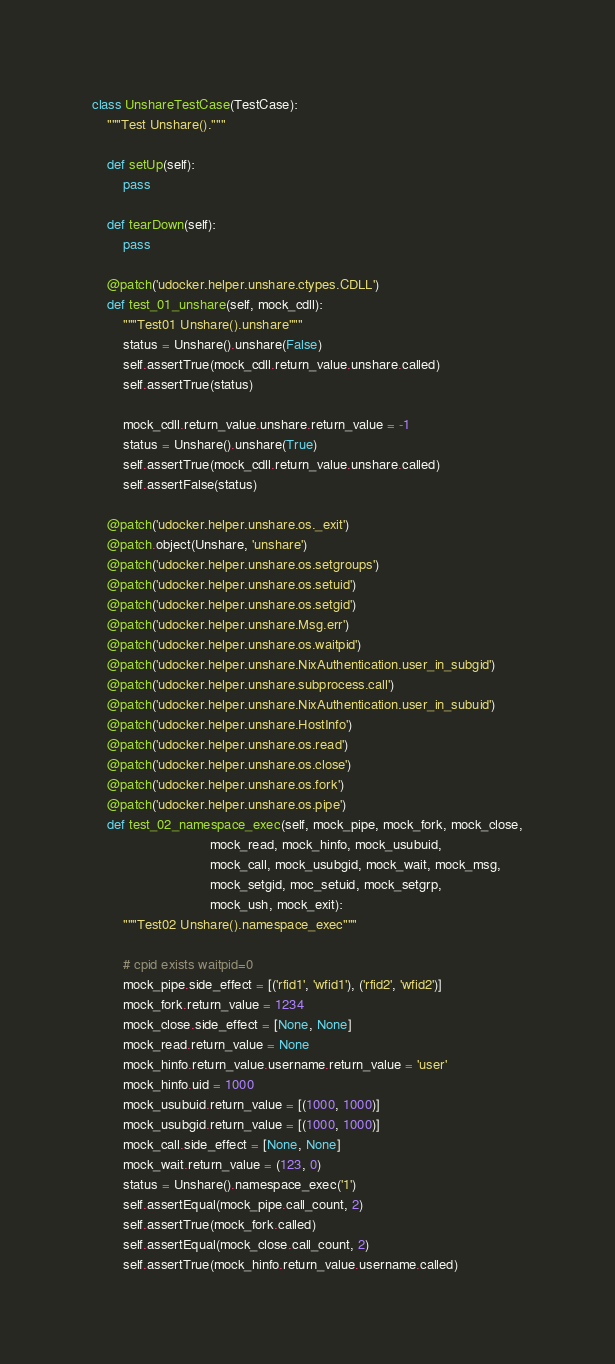Convert code to text. <code><loc_0><loc_0><loc_500><loc_500><_Python_>
class UnshareTestCase(TestCase):
    """Test Unshare()."""

    def setUp(self):
        pass

    def tearDown(self):
        pass

    @patch('udocker.helper.unshare.ctypes.CDLL')
    def test_01_unshare(self, mock_cdll):
        """Test01 Unshare().unshare"""
        status = Unshare().unshare(False)
        self.assertTrue(mock_cdll.return_value.unshare.called)
        self.assertTrue(status)

        mock_cdll.return_value.unshare.return_value = -1
        status = Unshare().unshare(True)
        self.assertTrue(mock_cdll.return_value.unshare.called)
        self.assertFalse(status)

    @patch('udocker.helper.unshare.os._exit')
    @patch.object(Unshare, 'unshare')
    @patch('udocker.helper.unshare.os.setgroups')
    @patch('udocker.helper.unshare.os.setuid')
    @patch('udocker.helper.unshare.os.setgid')
    @patch('udocker.helper.unshare.Msg.err')
    @patch('udocker.helper.unshare.os.waitpid')
    @patch('udocker.helper.unshare.NixAuthentication.user_in_subgid')
    @patch('udocker.helper.unshare.subprocess.call')
    @patch('udocker.helper.unshare.NixAuthentication.user_in_subuid')
    @patch('udocker.helper.unshare.HostInfo')
    @patch('udocker.helper.unshare.os.read')
    @patch('udocker.helper.unshare.os.close')
    @patch('udocker.helper.unshare.os.fork')
    @patch('udocker.helper.unshare.os.pipe')
    def test_02_namespace_exec(self, mock_pipe, mock_fork, mock_close,
                               mock_read, mock_hinfo, mock_usubuid,
                               mock_call, mock_usubgid, mock_wait, mock_msg,
                               mock_setgid, moc_setuid, mock_setgrp,
                               mock_ush, mock_exit):
        """Test02 Unshare().namespace_exec"""

        # cpid exists waitpid=0
        mock_pipe.side_effect = [('rfid1', 'wfid1'), ('rfid2', 'wfid2')]
        mock_fork.return_value = 1234
        mock_close.side_effect = [None, None]
        mock_read.return_value = None
        mock_hinfo.return_value.username.return_value = 'user'
        mock_hinfo.uid = 1000
        mock_usubuid.return_value = [(1000, 1000)]
        mock_usubgid.return_value = [(1000, 1000)]
        mock_call.side_effect = [None, None]
        mock_wait.return_value = (123, 0)
        status = Unshare().namespace_exec('1')
        self.assertEqual(mock_pipe.call_count, 2)
        self.assertTrue(mock_fork.called)
        self.assertEqual(mock_close.call_count, 2)
        self.assertTrue(mock_hinfo.return_value.username.called)</code> 